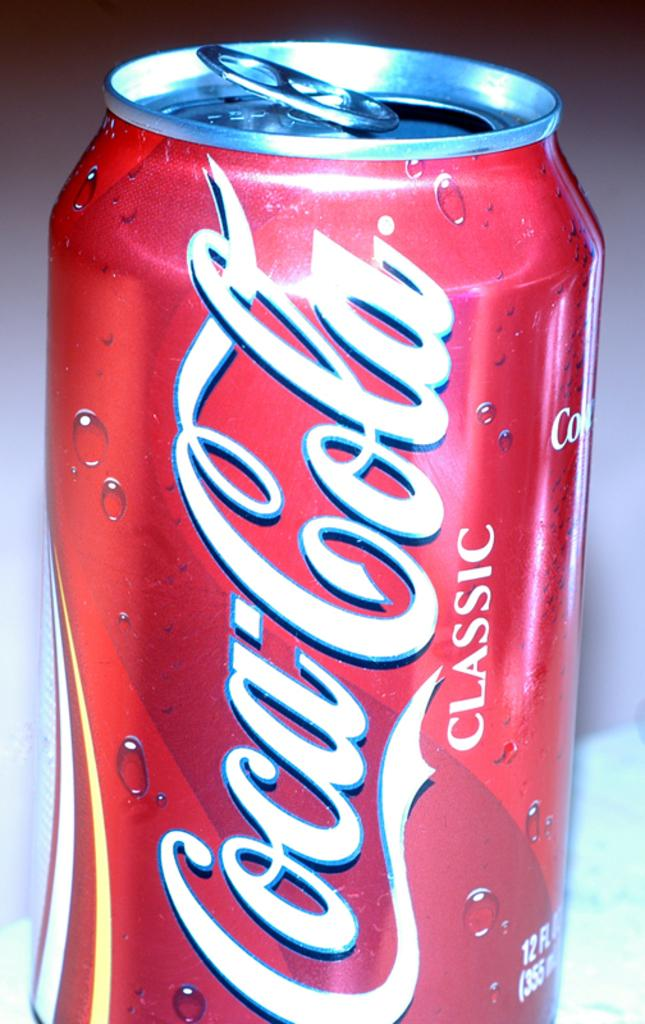<image>
Share a concise interpretation of the image provided. A can of Coca-Cola classic rests on a table, its tap pulled open. 